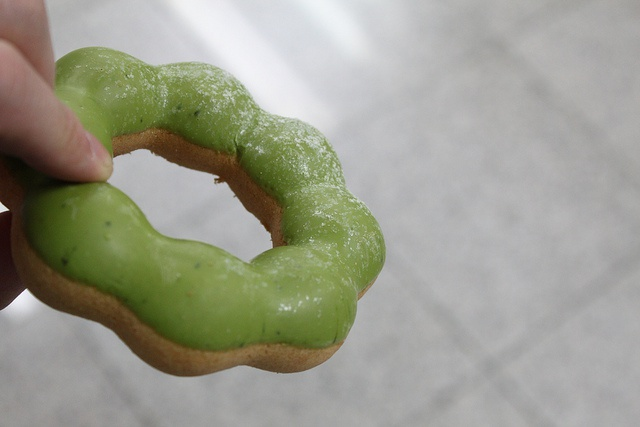Describe the objects in this image and their specific colors. I can see donut in gray, olive, and maroon tones and people in gray, brown, and maroon tones in this image. 